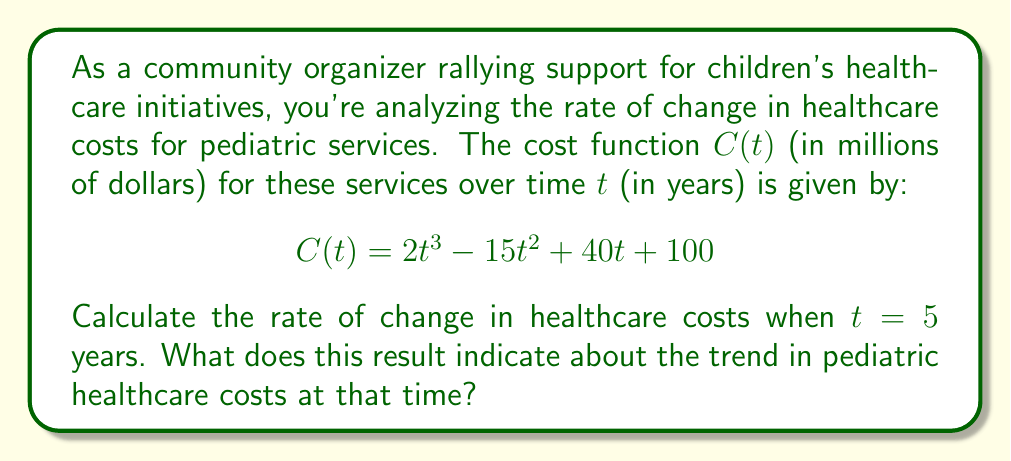Solve this math problem. To solve this problem, we need to follow these steps:

1) The rate of change of the cost function is given by its derivative. Let's call this function $C'(t)$.

2) To find $C'(t)$, we need to differentiate $C(t)$ with respect to $t$:

   $$C'(t) = \frac{d}{dt}(2t^3 - 15t^2 + 40t + 100)$$

3) Using the power rule and the constant rule of differentiation:

   $$C'(t) = 6t^2 - 30t + 40$$

4) Now, we need to evaluate $C'(t)$ at $t = 5$:

   $$C'(5) = 6(5)^2 - 30(5) + 40$$

5) Let's calculate this step by step:
   
   $$C'(5) = 6(25) - 150 + 40$$
   $$C'(5) = 150 - 150 + 40$$
   $$C'(5) = 40$$

6) Interpretation: The rate of change at $t = 5$ years is 40 million dollars per year. This positive value indicates that the healthcare costs for pediatric services are increasing at this point in time.
Answer: The rate of change in healthcare costs for pediatric services at $t = 5$ years is $C'(5) = 40$ million dollars per year, indicating an increasing trend in costs at that time. 